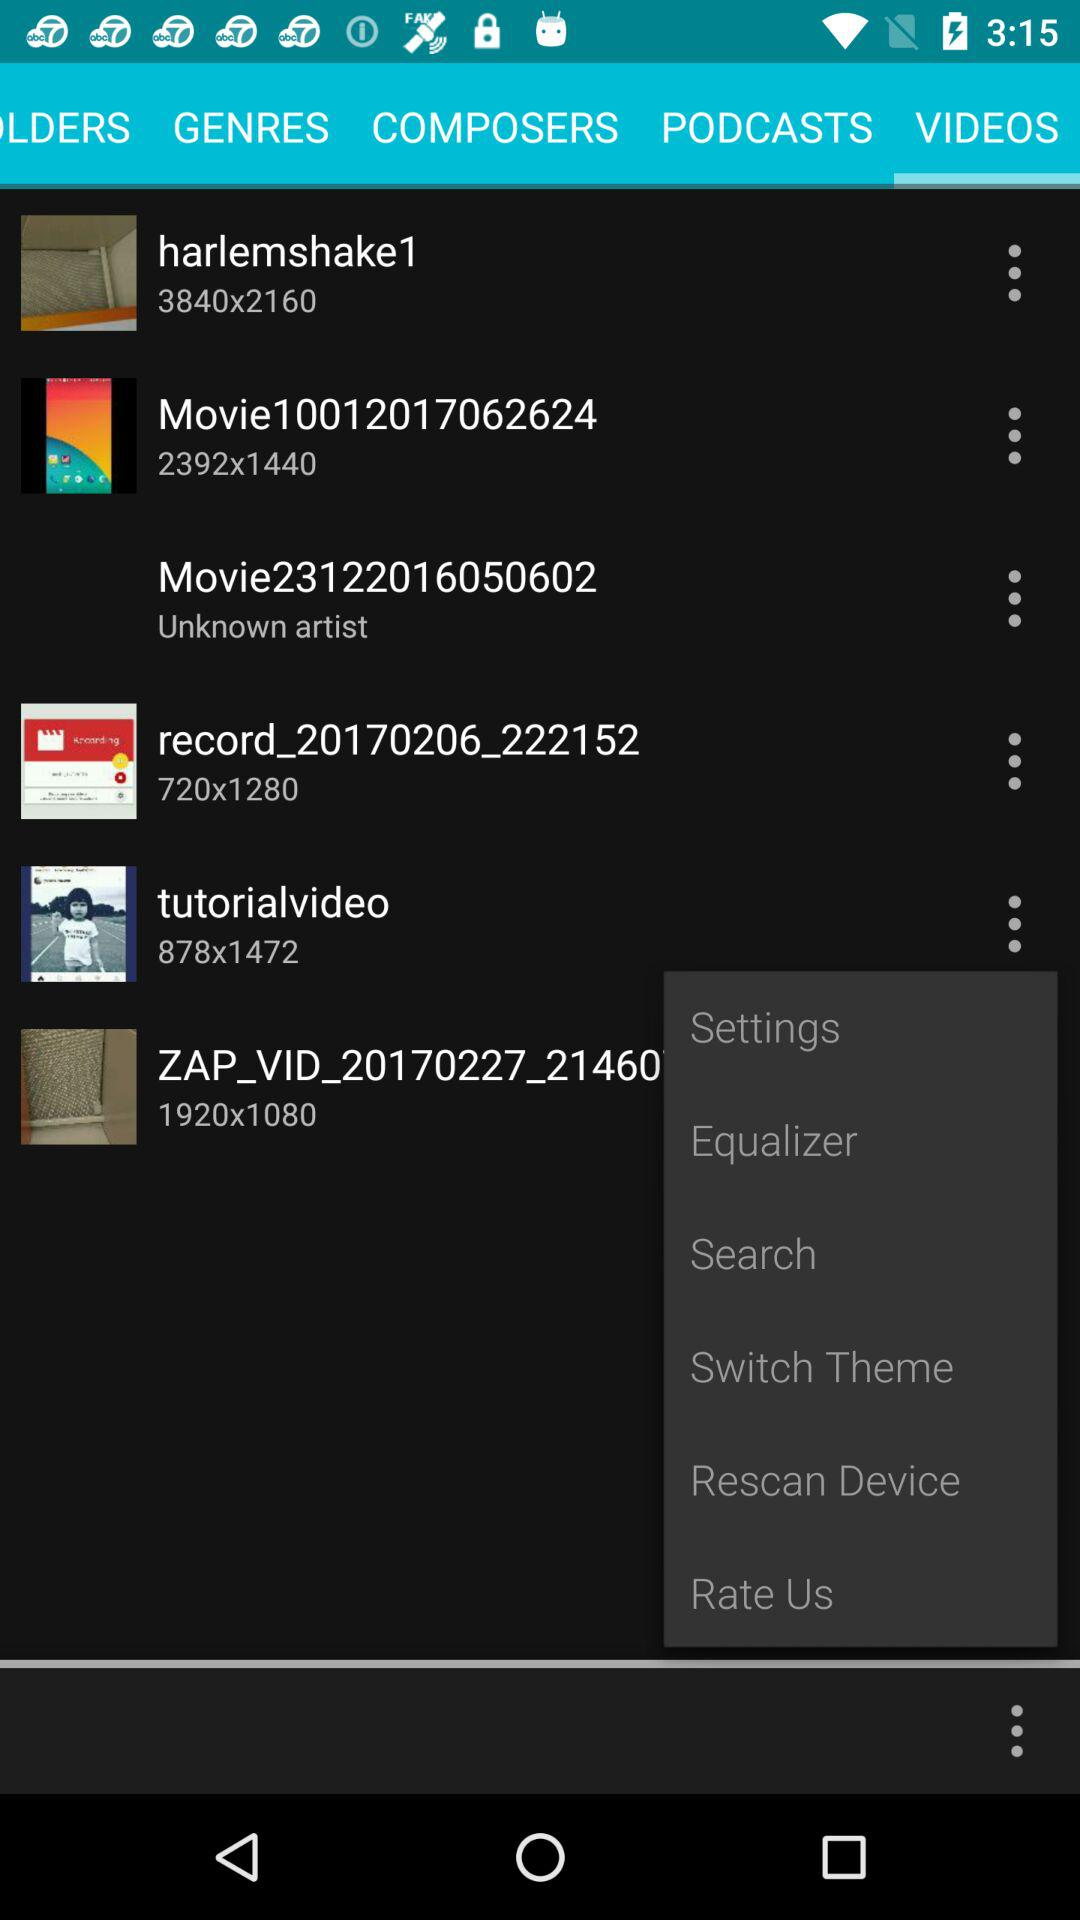What is the pixel size of the video "harlemshake1"? The pixel size is 3840×2160. 